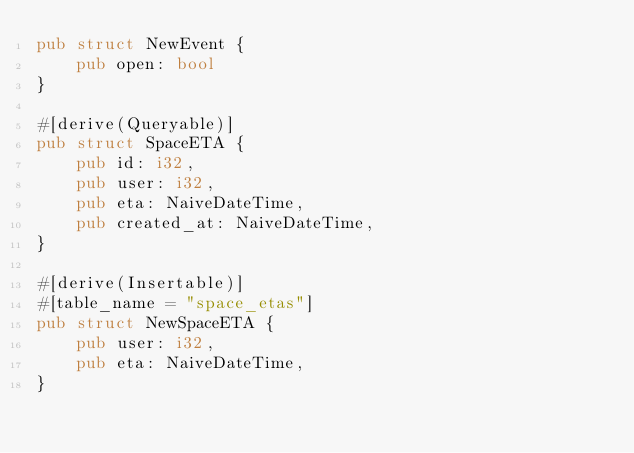<code> <loc_0><loc_0><loc_500><loc_500><_Rust_>pub struct NewEvent {
    pub open: bool
}

#[derive(Queryable)]
pub struct SpaceETA {
    pub id: i32,
    pub user: i32,
    pub eta: NaiveDateTime,
    pub created_at: NaiveDateTime,
}

#[derive(Insertable)]
#[table_name = "space_etas"]
pub struct NewSpaceETA {
    pub user: i32,
    pub eta: NaiveDateTime,
}</code> 